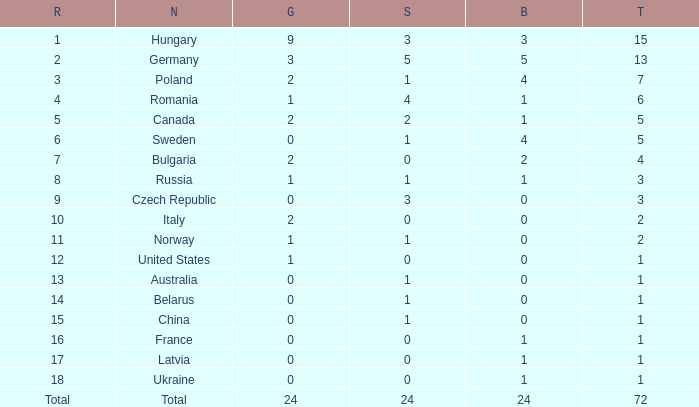How many golds have 3 as the rank, with a total greater than 7? 0.0. 